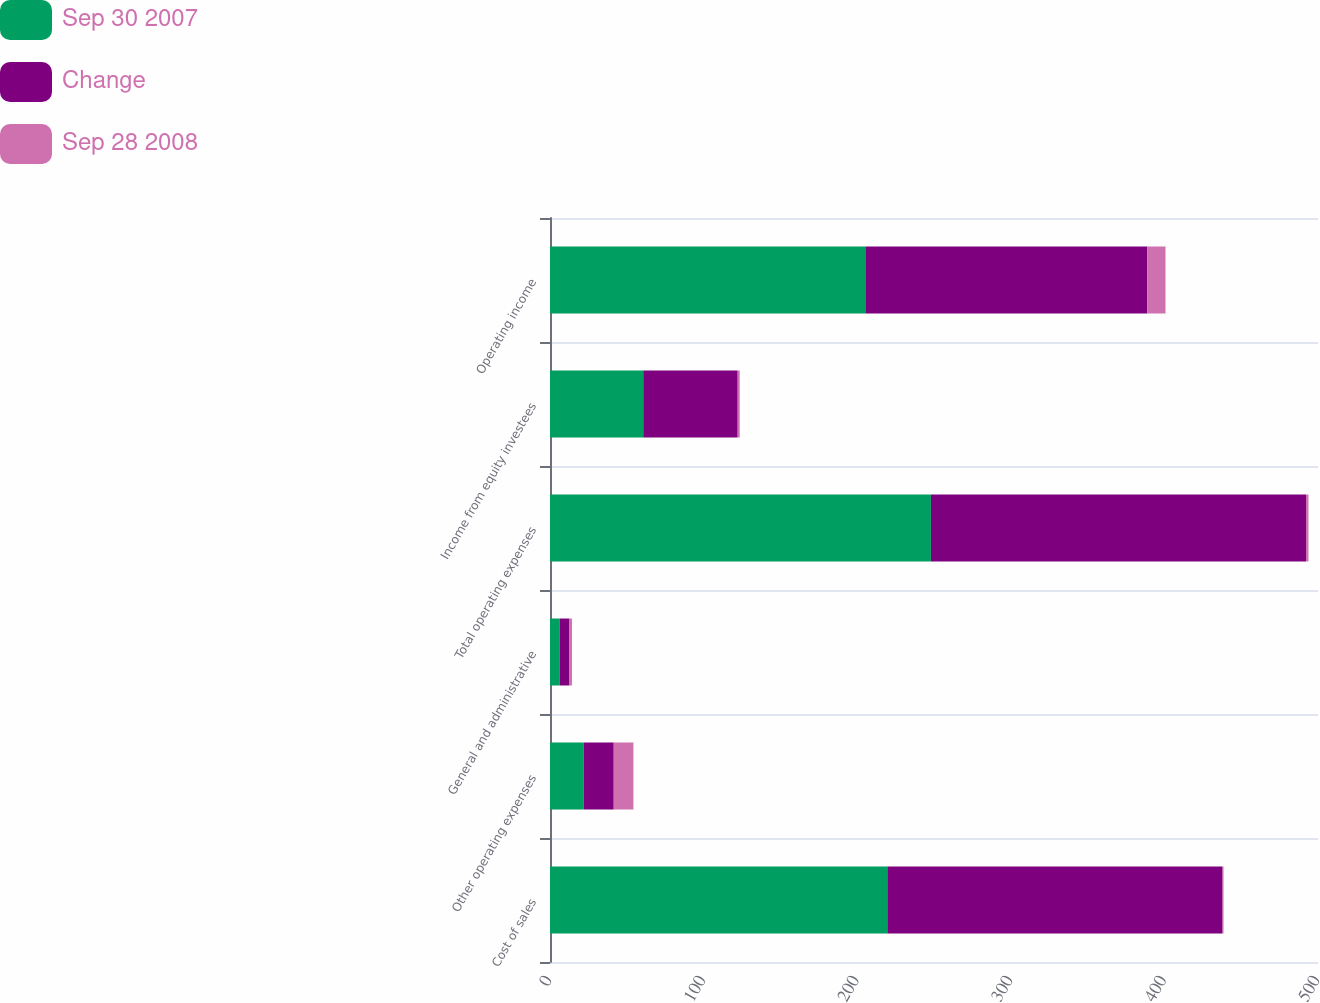Convert chart to OTSL. <chart><loc_0><loc_0><loc_500><loc_500><stacked_bar_chart><ecel><fcel>Cost of sales<fcel>Other operating expenses<fcel>General and administrative<fcel>Total operating expenses<fcel>Income from equity investees<fcel>Operating income<nl><fcel>Sep 30 2007<fcel>219.6<fcel>22<fcel>6.4<fcel>248<fcel>60.7<fcel>205.3<nl><fcel>Change<fcel>218.3<fcel>19.5<fcel>6.3<fcel>244.2<fcel>61.5<fcel>183.6<nl><fcel>Sep 28 2008<fcel>0.6<fcel>12.8<fcel>1.6<fcel>1.6<fcel>1.3<fcel>11.8<nl></chart> 